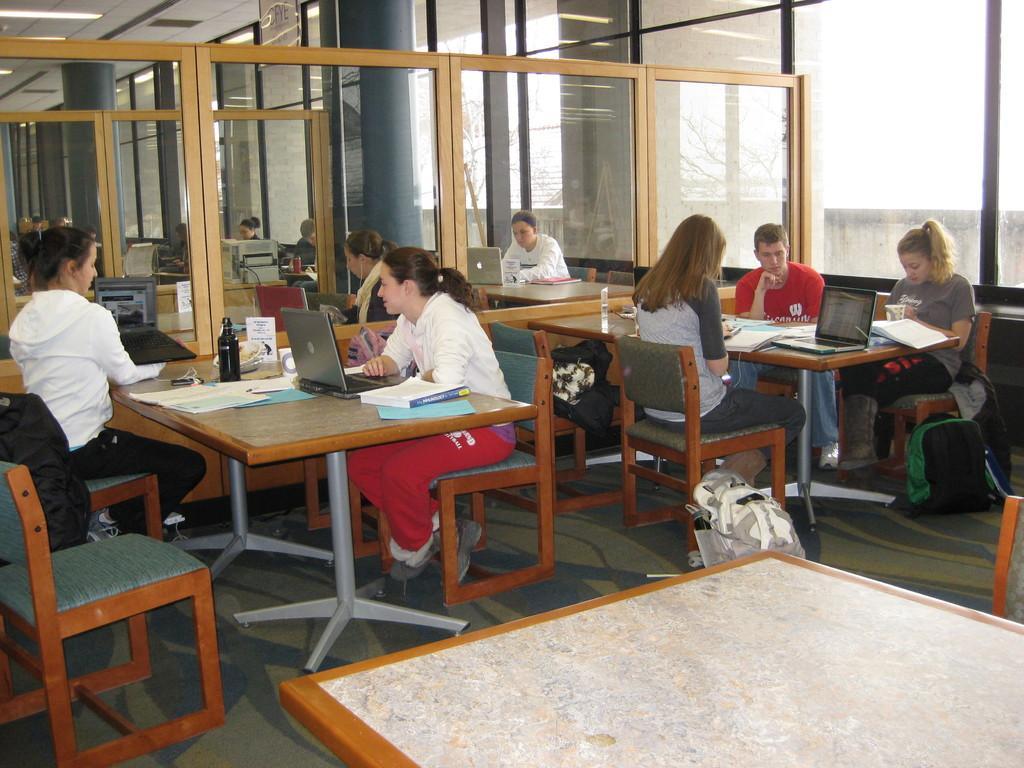Can you describe this image briefly? In this image i can see a number of people sitting on chairs in front of a table. On the table i can observe few books, laptops and bottles. In the background i can see glass windows and the roof. 